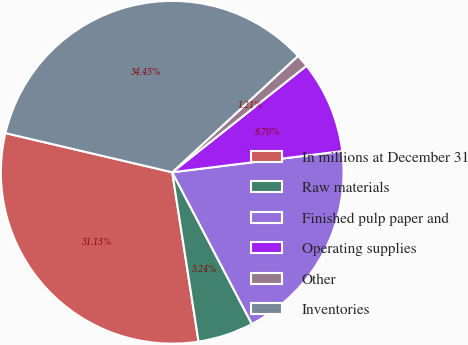Convert chart. <chart><loc_0><loc_0><loc_500><loc_500><pie_chart><fcel>In millions at December 31<fcel>Raw materials<fcel>Finished pulp paper and<fcel>Operating supplies<fcel>Other<fcel>Inventories<nl><fcel>31.13%<fcel>5.24%<fcel>19.28%<fcel>8.7%<fcel>1.21%<fcel>34.45%<nl></chart> 